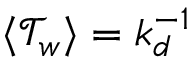<formula> <loc_0><loc_0><loc_500><loc_500>\langle \mathcal { T } _ { w } \rangle = k _ { d } ^ { - 1 }</formula> 